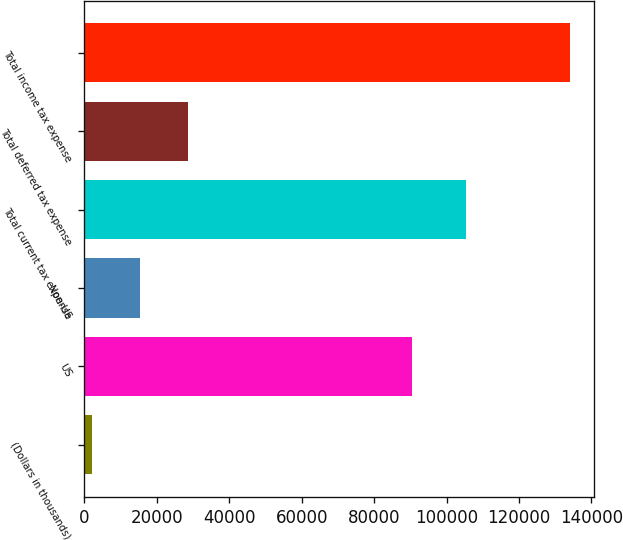Convert chart to OTSL. <chart><loc_0><loc_0><loc_500><loc_500><bar_chart><fcel>(Dollars in thousands)<fcel>US<fcel>Non-US<fcel>Total current tax expense<fcel>Total deferred tax expense<fcel>Total income tax expense<nl><fcel>2015<fcel>90486<fcel>15215.6<fcel>105297<fcel>28724<fcel>134021<nl></chart> 